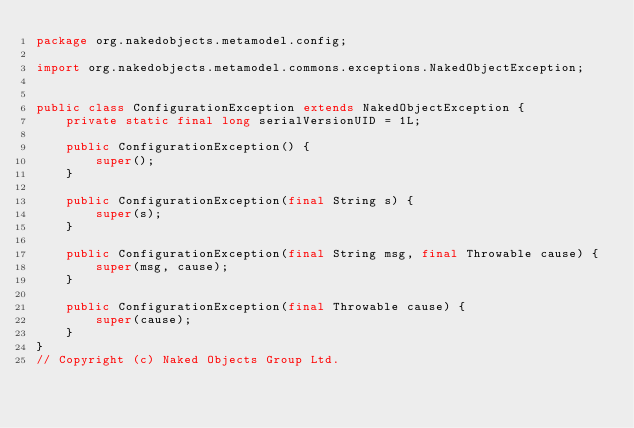<code> <loc_0><loc_0><loc_500><loc_500><_Java_>package org.nakedobjects.metamodel.config;

import org.nakedobjects.metamodel.commons.exceptions.NakedObjectException;


public class ConfigurationException extends NakedObjectException {
    private static final long serialVersionUID = 1L;

    public ConfigurationException() {
        super();
    }

    public ConfigurationException(final String s) {
        super(s);
    }

    public ConfigurationException(final String msg, final Throwable cause) {
        super(msg, cause);
    }

    public ConfigurationException(final Throwable cause) {
        super(cause);
    }
}
// Copyright (c) Naked Objects Group Ltd.
</code> 